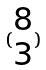Convert formula to latex. <formula><loc_0><loc_0><loc_500><loc_500>( \begin{matrix} 8 \\ 3 \end{matrix} )</formula> 